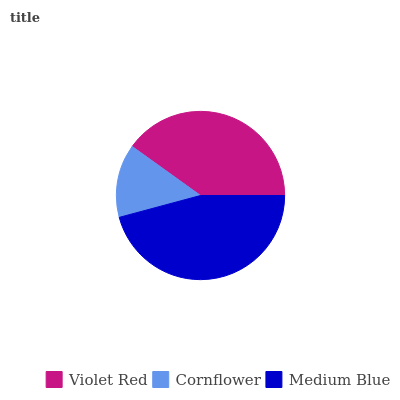Is Cornflower the minimum?
Answer yes or no. Yes. Is Medium Blue the maximum?
Answer yes or no. Yes. Is Medium Blue the minimum?
Answer yes or no. No. Is Cornflower the maximum?
Answer yes or no. No. Is Medium Blue greater than Cornflower?
Answer yes or no. Yes. Is Cornflower less than Medium Blue?
Answer yes or no. Yes. Is Cornflower greater than Medium Blue?
Answer yes or no. No. Is Medium Blue less than Cornflower?
Answer yes or no. No. Is Violet Red the high median?
Answer yes or no. Yes. Is Violet Red the low median?
Answer yes or no. Yes. Is Medium Blue the high median?
Answer yes or no. No. Is Medium Blue the low median?
Answer yes or no. No. 